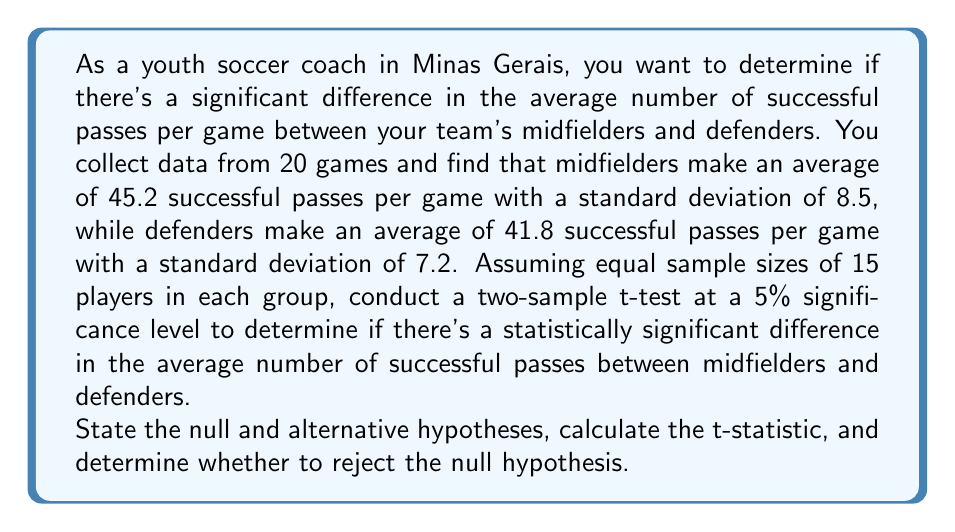Can you solve this math problem? Let's approach this step-by-step:

1) First, let's state our hypotheses:
   Null hypothesis (H₀): $\mu_m - \mu_d = 0$
   Alternative hypothesis (H₁): $\mu_m - \mu_d \neq 0$
   Where $\mu_m$ is the population mean for midfielders and $\mu_d$ is the population mean for defenders.

2) We'll use a two-sample t-test. The formula for the t-statistic is:

   $$t = \frac{\bar{X}_1 - \bar{X}_2}{\sqrt{\frac{s_1^2}{n_1} + \frac{s_2^2}{n_2}}}$$

   Where:
   $\bar{X}_1$ and $\bar{X}_2$ are the sample means
   $s_1$ and $s_2$ are the sample standard deviations
   $n_1$ and $n_2$ are the sample sizes

3) Let's plug in our values:
   $\bar{X}_1 = 45.2$ (midfielders)
   $\bar{X}_2 = 41.8$ (defenders)
   $s_1 = 8.5$
   $s_2 = 7.2$
   $n_1 = n_2 = 15$

4) Calculating the t-statistic:

   $$t = \frac{45.2 - 41.8}{\sqrt{\frac{8.5^2}{15} + \frac{7.2^2}{15}}} = \frac{3.4}{\sqrt{4.81 + 3.46}} = \frac{3.4}{\sqrt{8.27}} = \frac{3.4}{2.88} = 1.18$$

5) To determine whether to reject the null hypothesis, we need to compare this t-value to the critical t-value for a two-tailed test at a 5% significance level with degrees of freedom:

   $df = n_1 + n_2 - 2 = 15 + 15 - 2 = 28$

6) The critical t-value for a two-tailed test with 28 degrees of freedom at a 5% significance level is approximately ±2.048.

7) Since our calculated t-value (1.18) is less than the critical t-value (2.048), we fail to reject the null hypothesis.
Answer: Fail to reject the null hypothesis. There is not enough evidence to conclude that there is a statistically significant difference in the average number of successful passes per game between midfielders and defenders (t = 1.18, df = 28, p > 0.05). 